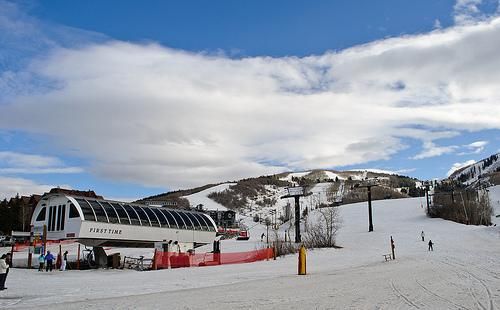Mention a prominent feature of the landscape in the image. A tall, snow-covered mountain can be seen dominating the landscape. In a single sentence, summarize the overall scene depicted in the image. On a cloudy blue day, various groups of people are skiing and snowboarding down a snow-covered mountain, surrounded by white buildings, fences, and poles. Describe the main activity taking place in the image. Groups of people are skiing and snowboarding on the snowy slopes of a mountain. Describe a miscellaneous feature of the scene. There is a yellow pole and a black pole - both large - standing in the snow near the slope. What type of clothing are some people wearing in the image? One person is wearing a blue jacket, another is wearing an aqua jacket, and a third is wearing a white jacket. Mention a striking man-made feature in the snowy landscape. A red mesh fence can be seen running across the snow on the slope. In one sentence, describe the ski slope and its surroundings. The image depicts a snow-covered ski slope surrounded by mountains, buildings, and people engaging in winter sports. Provide a brief description of the atmospheric condition in the image. The image shows a cloudy blue day with long white clouds scattered across the blue sky. What kind of infrastructure can be seen in the image? A white building, possibly a ski lodge, is visible amidst the snow, with people standing in front of it. Mention a small, yet significant detail about the infrastructure visible in the image. A row of windows can be seen on top of the white building along with words written on its side. 